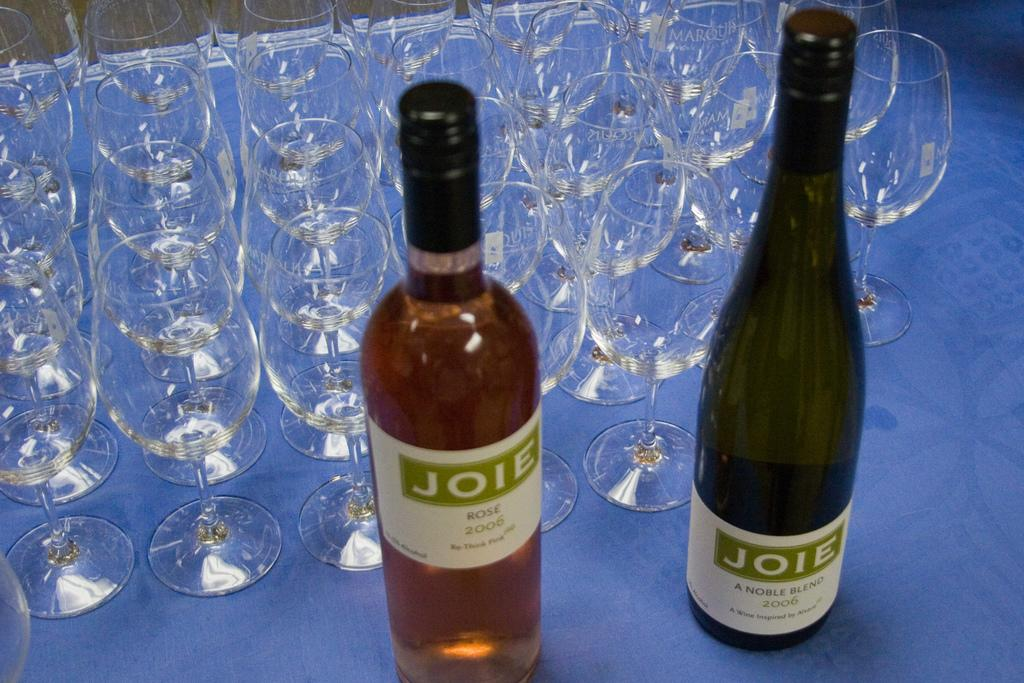<image>
Share a concise interpretation of the image provided. Two bottles of Joie alcohol sit on a blue table surrounded by wine glasses. 